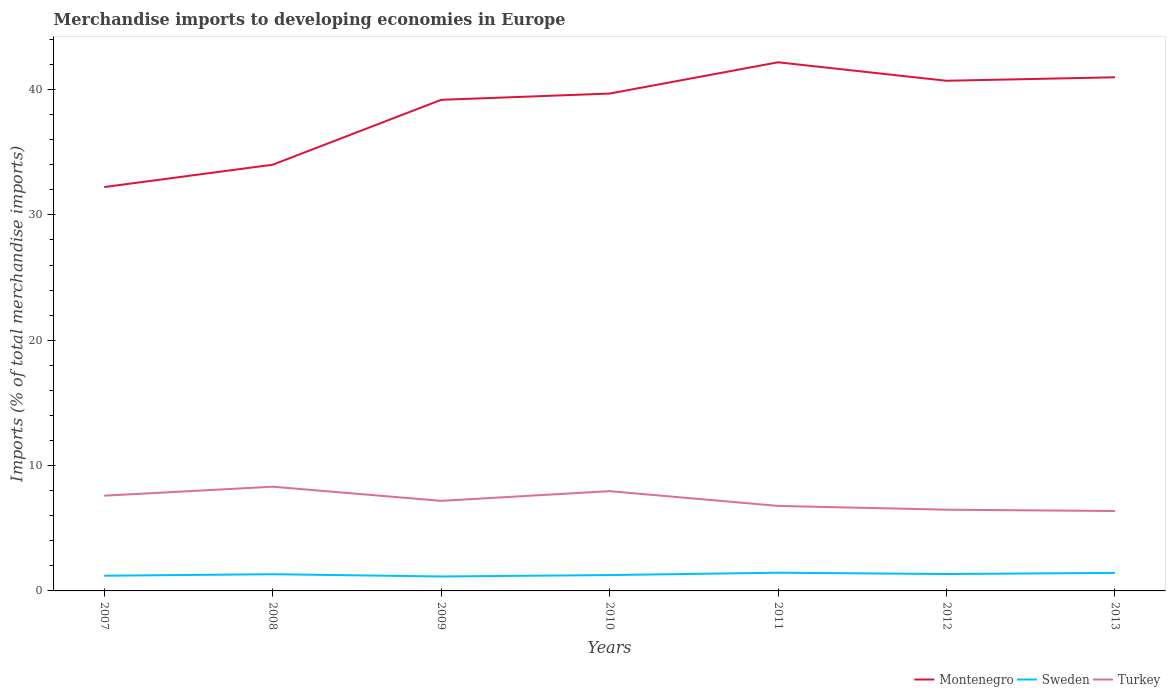How many different coloured lines are there?
Provide a succinct answer. 3. Does the line corresponding to Turkey intersect with the line corresponding to Sweden?
Offer a terse response. No. Across all years, what is the maximum percentage total merchandise imports in Sweden?
Ensure brevity in your answer.  1.15. In which year was the percentage total merchandise imports in Montenegro maximum?
Offer a very short reply. 2007. What is the total percentage total merchandise imports in Montenegro in the graph?
Offer a very short reply. 1.2. What is the difference between the highest and the second highest percentage total merchandise imports in Turkey?
Provide a succinct answer. 1.94. What is the difference between the highest and the lowest percentage total merchandise imports in Turkey?
Offer a terse response. 3. Is the percentage total merchandise imports in Sweden strictly greater than the percentage total merchandise imports in Turkey over the years?
Your answer should be very brief. Yes. How many years are there in the graph?
Provide a short and direct response. 7. Are the values on the major ticks of Y-axis written in scientific E-notation?
Provide a short and direct response. No. Does the graph contain any zero values?
Offer a very short reply. No. How many legend labels are there?
Your response must be concise. 3. How are the legend labels stacked?
Your answer should be very brief. Horizontal. What is the title of the graph?
Give a very brief answer. Merchandise imports to developing economies in Europe. Does "Bulgaria" appear as one of the legend labels in the graph?
Keep it short and to the point. No. What is the label or title of the Y-axis?
Make the answer very short. Imports (% of total merchandise imports). What is the Imports (% of total merchandise imports) of Montenegro in 2007?
Your answer should be very brief. 32.22. What is the Imports (% of total merchandise imports) of Sweden in 2007?
Offer a terse response. 1.21. What is the Imports (% of total merchandise imports) in Turkey in 2007?
Provide a short and direct response. 7.6. What is the Imports (% of total merchandise imports) in Montenegro in 2008?
Your answer should be very brief. 34. What is the Imports (% of total merchandise imports) of Sweden in 2008?
Offer a very short reply. 1.33. What is the Imports (% of total merchandise imports) of Turkey in 2008?
Ensure brevity in your answer.  8.31. What is the Imports (% of total merchandise imports) in Montenegro in 2009?
Provide a short and direct response. 39.18. What is the Imports (% of total merchandise imports) in Sweden in 2009?
Offer a terse response. 1.15. What is the Imports (% of total merchandise imports) of Turkey in 2009?
Make the answer very short. 7.19. What is the Imports (% of total merchandise imports) in Montenegro in 2010?
Provide a succinct answer. 39.68. What is the Imports (% of total merchandise imports) of Sweden in 2010?
Offer a terse response. 1.26. What is the Imports (% of total merchandise imports) in Turkey in 2010?
Make the answer very short. 7.96. What is the Imports (% of total merchandise imports) in Montenegro in 2011?
Offer a very short reply. 42.17. What is the Imports (% of total merchandise imports) in Sweden in 2011?
Your response must be concise. 1.45. What is the Imports (% of total merchandise imports) of Turkey in 2011?
Your response must be concise. 6.78. What is the Imports (% of total merchandise imports) of Montenegro in 2012?
Offer a terse response. 40.7. What is the Imports (% of total merchandise imports) in Sweden in 2012?
Offer a terse response. 1.35. What is the Imports (% of total merchandise imports) of Turkey in 2012?
Provide a succinct answer. 6.48. What is the Imports (% of total merchandise imports) in Montenegro in 2013?
Offer a terse response. 40.98. What is the Imports (% of total merchandise imports) in Sweden in 2013?
Offer a terse response. 1.44. What is the Imports (% of total merchandise imports) of Turkey in 2013?
Ensure brevity in your answer.  6.37. Across all years, what is the maximum Imports (% of total merchandise imports) of Montenegro?
Offer a terse response. 42.17. Across all years, what is the maximum Imports (% of total merchandise imports) of Sweden?
Make the answer very short. 1.45. Across all years, what is the maximum Imports (% of total merchandise imports) in Turkey?
Ensure brevity in your answer.  8.31. Across all years, what is the minimum Imports (% of total merchandise imports) in Montenegro?
Your response must be concise. 32.22. Across all years, what is the minimum Imports (% of total merchandise imports) of Sweden?
Provide a short and direct response. 1.15. Across all years, what is the minimum Imports (% of total merchandise imports) in Turkey?
Give a very brief answer. 6.37. What is the total Imports (% of total merchandise imports) in Montenegro in the graph?
Your response must be concise. 268.93. What is the total Imports (% of total merchandise imports) in Sweden in the graph?
Offer a terse response. 9.2. What is the total Imports (% of total merchandise imports) of Turkey in the graph?
Offer a terse response. 50.7. What is the difference between the Imports (% of total merchandise imports) of Montenegro in 2007 and that in 2008?
Keep it short and to the point. -1.78. What is the difference between the Imports (% of total merchandise imports) of Sweden in 2007 and that in 2008?
Keep it short and to the point. -0.12. What is the difference between the Imports (% of total merchandise imports) of Turkey in 2007 and that in 2008?
Keep it short and to the point. -0.72. What is the difference between the Imports (% of total merchandise imports) in Montenegro in 2007 and that in 2009?
Your answer should be compact. -6.96. What is the difference between the Imports (% of total merchandise imports) of Sweden in 2007 and that in 2009?
Offer a very short reply. 0.06. What is the difference between the Imports (% of total merchandise imports) in Turkey in 2007 and that in 2009?
Make the answer very short. 0.41. What is the difference between the Imports (% of total merchandise imports) in Montenegro in 2007 and that in 2010?
Your answer should be compact. -7.46. What is the difference between the Imports (% of total merchandise imports) of Sweden in 2007 and that in 2010?
Offer a very short reply. -0.05. What is the difference between the Imports (% of total merchandise imports) of Turkey in 2007 and that in 2010?
Provide a short and direct response. -0.36. What is the difference between the Imports (% of total merchandise imports) in Montenegro in 2007 and that in 2011?
Offer a terse response. -9.95. What is the difference between the Imports (% of total merchandise imports) of Sweden in 2007 and that in 2011?
Your answer should be very brief. -0.24. What is the difference between the Imports (% of total merchandise imports) in Turkey in 2007 and that in 2011?
Your response must be concise. 0.82. What is the difference between the Imports (% of total merchandise imports) of Montenegro in 2007 and that in 2012?
Give a very brief answer. -8.48. What is the difference between the Imports (% of total merchandise imports) of Sweden in 2007 and that in 2012?
Provide a short and direct response. -0.13. What is the difference between the Imports (% of total merchandise imports) in Turkey in 2007 and that in 2012?
Your answer should be compact. 1.12. What is the difference between the Imports (% of total merchandise imports) of Montenegro in 2007 and that in 2013?
Give a very brief answer. -8.76. What is the difference between the Imports (% of total merchandise imports) of Sweden in 2007 and that in 2013?
Offer a terse response. -0.23. What is the difference between the Imports (% of total merchandise imports) in Turkey in 2007 and that in 2013?
Keep it short and to the point. 1.22. What is the difference between the Imports (% of total merchandise imports) of Montenegro in 2008 and that in 2009?
Ensure brevity in your answer.  -5.18. What is the difference between the Imports (% of total merchandise imports) in Sweden in 2008 and that in 2009?
Make the answer very short. 0.18. What is the difference between the Imports (% of total merchandise imports) of Turkey in 2008 and that in 2009?
Keep it short and to the point. 1.13. What is the difference between the Imports (% of total merchandise imports) in Montenegro in 2008 and that in 2010?
Provide a succinct answer. -5.68. What is the difference between the Imports (% of total merchandise imports) in Sweden in 2008 and that in 2010?
Provide a short and direct response. 0.07. What is the difference between the Imports (% of total merchandise imports) in Turkey in 2008 and that in 2010?
Make the answer very short. 0.35. What is the difference between the Imports (% of total merchandise imports) in Montenegro in 2008 and that in 2011?
Keep it short and to the point. -8.17. What is the difference between the Imports (% of total merchandise imports) in Sweden in 2008 and that in 2011?
Make the answer very short. -0.12. What is the difference between the Imports (% of total merchandise imports) of Turkey in 2008 and that in 2011?
Ensure brevity in your answer.  1.53. What is the difference between the Imports (% of total merchandise imports) in Montenegro in 2008 and that in 2012?
Your answer should be compact. -6.7. What is the difference between the Imports (% of total merchandise imports) in Sweden in 2008 and that in 2012?
Offer a very short reply. -0.01. What is the difference between the Imports (% of total merchandise imports) of Turkey in 2008 and that in 2012?
Provide a short and direct response. 1.83. What is the difference between the Imports (% of total merchandise imports) of Montenegro in 2008 and that in 2013?
Give a very brief answer. -6.97. What is the difference between the Imports (% of total merchandise imports) in Sweden in 2008 and that in 2013?
Your answer should be compact. -0.11. What is the difference between the Imports (% of total merchandise imports) of Turkey in 2008 and that in 2013?
Your answer should be compact. 1.94. What is the difference between the Imports (% of total merchandise imports) of Montenegro in 2009 and that in 2010?
Provide a succinct answer. -0.5. What is the difference between the Imports (% of total merchandise imports) in Sweden in 2009 and that in 2010?
Offer a very short reply. -0.11. What is the difference between the Imports (% of total merchandise imports) of Turkey in 2009 and that in 2010?
Your answer should be very brief. -0.77. What is the difference between the Imports (% of total merchandise imports) of Montenegro in 2009 and that in 2011?
Offer a very short reply. -2.99. What is the difference between the Imports (% of total merchandise imports) in Sweden in 2009 and that in 2011?
Offer a very short reply. -0.3. What is the difference between the Imports (% of total merchandise imports) in Turkey in 2009 and that in 2011?
Your answer should be compact. 0.41. What is the difference between the Imports (% of total merchandise imports) of Montenegro in 2009 and that in 2012?
Your response must be concise. -1.52. What is the difference between the Imports (% of total merchandise imports) in Sweden in 2009 and that in 2012?
Keep it short and to the point. -0.19. What is the difference between the Imports (% of total merchandise imports) of Turkey in 2009 and that in 2012?
Offer a terse response. 0.71. What is the difference between the Imports (% of total merchandise imports) of Montenegro in 2009 and that in 2013?
Your answer should be very brief. -1.8. What is the difference between the Imports (% of total merchandise imports) of Sweden in 2009 and that in 2013?
Provide a short and direct response. -0.29. What is the difference between the Imports (% of total merchandise imports) in Turkey in 2009 and that in 2013?
Your answer should be very brief. 0.81. What is the difference between the Imports (% of total merchandise imports) of Montenegro in 2010 and that in 2011?
Ensure brevity in your answer.  -2.49. What is the difference between the Imports (% of total merchandise imports) of Sweden in 2010 and that in 2011?
Make the answer very short. -0.19. What is the difference between the Imports (% of total merchandise imports) of Turkey in 2010 and that in 2011?
Your response must be concise. 1.18. What is the difference between the Imports (% of total merchandise imports) in Montenegro in 2010 and that in 2012?
Make the answer very short. -1.02. What is the difference between the Imports (% of total merchandise imports) of Sweden in 2010 and that in 2012?
Ensure brevity in your answer.  -0.08. What is the difference between the Imports (% of total merchandise imports) in Turkey in 2010 and that in 2012?
Give a very brief answer. 1.48. What is the difference between the Imports (% of total merchandise imports) in Montenegro in 2010 and that in 2013?
Your answer should be compact. -1.3. What is the difference between the Imports (% of total merchandise imports) in Sweden in 2010 and that in 2013?
Make the answer very short. -0.18. What is the difference between the Imports (% of total merchandise imports) in Turkey in 2010 and that in 2013?
Give a very brief answer. 1.59. What is the difference between the Imports (% of total merchandise imports) of Montenegro in 2011 and that in 2012?
Provide a succinct answer. 1.47. What is the difference between the Imports (% of total merchandise imports) in Sweden in 2011 and that in 2012?
Provide a succinct answer. 0.11. What is the difference between the Imports (% of total merchandise imports) in Turkey in 2011 and that in 2012?
Ensure brevity in your answer.  0.3. What is the difference between the Imports (% of total merchandise imports) of Montenegro in 2011 and that in 2013?
Keep it short and to the point. 1.2. What is the difference between the Imports (% of total merchandise imports) in Sweden in 2011 and that in 2013?
Provide a short and direct response. 0.01. What is the difference between the Imports (% of total merchandise imports) of Turkey in 2011 and that in 2013?
Ensure brevity in your answer.  0.41. What is the difference between the Imports (% of total merchandise imports) in Montenegro in 2012 and that in 2013?
Give a very brief answer. -0.28. What is the difference between the Imports (% of total merchandise imports) of Sweden in 2012 and that in 2013?
Your answer should be compact. -0.09. What is the difference between the Imports (% of total merchandise imports) in Turkey in 2012 and that in 2013?
Offer a terse response. 0.11. What is the difference between the Imports (% of total merchandise imports) of Montenegro in 2007 and the Imports (% of total merchandise imports) of Sweden in 2008?
Give a very brief answer. 30.89. What is the difference between the Imports (% of total merchandise imports) in Montenegro in 2007 and the Imports (% of total merchandise imports) in Turkey in 2008?
Offer a very short reply. 23.9. What is the difference between the Imports (% of total merchandise imports) in Sweden in 2007 and the Imports (% of total merchandise imports) in Turkey in 2008?
Your answer should be very brief. -7.1. What is the difference between the Imports (% of total merchandise imports) in Montenegro in 2007 and the Imports (% of total merchandise imports) in Sweden in 2009?
Give a very brief answer. 31.07. What is the difference between the Imports (% of total merchandise imports) in Montenegro in 2007 and the Imports (% of total merchandise imports) in Turkey in 2009?
Offer a terse response. 25.03. What is the difference between the Imports (% of total merchandise imports) of Sweden in 2007 and the Imports (% of total merchandise imports) of Turkey in 2009?
Make the answer very short. -5.97. What is the difference between the Imports (% of total merchandise imports) of Montenegro in 2007 and the Imports (% of total merchandise imports) of Sweden in 2010?
Give a very brief answer. 30.95. What is the difference between the Imports (% of total merchandise imports) in Montenegro in 2007 and the Imports (% of total merchandise imports) in Turkey in 2010?
Ensure brevity in your answer.  24.26. What is the difference between the Imports (% of total merchandise imports) of Sweden in 2007 and the Imports (% of total merchandise imports) of Turkey in 2010?
Your answer should be compact. -6.75. What is the difference between the Imports (% of total merchandise imports) of Montenegro in 2007 and the Imports (% of total merchandise imports) of Sweden in 2011?
Ensure brevity in your answer.  30.76. What is the difference between the Imports (% of total merchandise imports) in Montenegro in 2007 and the Imports (% of total merchandise imports) in Turkey in 2011?
Provide a short and direct response. 25.44. What is the difference between the Imports (% of total merchandise imports) of Sweden in 2007 and the Imports (% of total merchandise imports) of Turkey in 2011?
Ensure brevity in your answer.  -5.57. What is the difference between the Imports (% of total merchandise imports) in Montenegro in 2007 and the Imports (% of total merchandise imports) in Sweden in 2012?
Your answer should be compact. 30.87. What is the difference between the Imports (% of total merchandise imports) in Montenegro in 2007 and the Imports (% of total merchandise imports) in Turkey in 2012?
Provide a short and direct response. 25.74. What is the difference between the Imports (% of total merchandise imports) in Sweden in 2007 and the Imports (% of total merchandise imports) in Turkey in 2012?
Provide a short and direct response. -5.27. What is the difference between the Imports (% of total merchandise imports) of Montenegro in 2007 and the Imports (% of total merchandise imports) of Sweden in 2013?
Keep it short and to the point. 30.78. What is the difference between the Imports (% of total merchandise imports) in Montenegro in 2007 and the Imports (% of total merchandise imports) in Turkey in 2013?
Offer a very short reply. 25.84. What is the difference between the Imports (% of total merchandise imports) in Sweden in 2007 and the Imports (% of total merchandise imports) in Turkey in 2013?
Provide a short and direct response. -5.16. What is the difference between the Imports (% of total merchandise imports) of Montenegro in 2008 and the Imports (% of total merchandise imports) of Sweden in 2009?
Give a very brief answer. 32.85. What is the difference between the Imports (% of total merchandise imports) in Montenegro in 2008 and the Imports (% of total merchandise imports) in Turkey in 2009?
Provide a short and direct response. 26.82. What is the difference between the Imports (% of total merchandise imports) of Sweden in 2008 and the Imports (% of total merchandise imports) of Turkey in 2009?
Your answer should be compact. -5.85. What is the difference between the Imports (% of total merchandise imports) in Montenegro in 2008 and the Imports (% of total merchandise imports) in Sweden in 2010?
Ensure brevity in your answer.  32.74. What is the difference between the Imports (% of total merchandise imports) of Montenegro in 2008 and the Imports (% of total merchandise imports) of Turkey in 2010?
Make the answer very short. 26.04. What is the difference between the Imports (% of total merchandise imports) in Sweden in 2008 and the Imports (% of total merchandise imports) in Turkey in 2010?
Ensure brevity in your answer.  -6.63. What is the difference between the Imports (% of total merchandise imports) of Montenegro in 2008 and the Imports (% of total merchandise imports) of Sweden in 2011?
Keep it short and to the point. 32.55. What is the difference between the Imports (% of total merchandise imports) of Montenegro in 2008 and the Imports (% of total merchandise imports) of Turkey in 2011?
Make the answer very short. 27.22. What is the difference between the Imports (% of total merchandise imports) in Sweden in 2008 and the Imports (% of total merchandise imports) in Turkey in 2011?
Your answer should be compact. -5.45. What is the difference between the Imports (% of total merchandise imports) of Montenegro in 2008 and the Imports (% of total merchandise imports) of Sweden in 2012?
Your response must be concise. 32.65. What is the difference between the Imports (% of total merchandise imports) of Montenegro in 2008 and the Imports (% of total merchandise imports) of Turkey in 2012?
Give a very brief answer. 27.52. What is the difference between the Imports (% of total merchandise imports) of Sweden in 2008 and the Imports (% of total merchandise imports) of Turkey in 2012?
Offer a terse response. -5.15. What is the difference between the Imports (% of total merchandise imports) of Montenegro in 2008 and the Imports (% of total merchandise imports) of Sweden in 2013?
Provide a succinct answer. 32.56. What is the difference between the Imports (% of total merchandise imports) in Montenegro in 2008 and the Imports (% of total merchandise imports) in Turkey in 2013?
Give a very brief answer. 27.63. What is the difference between the Imports (% of total merchandise imports) of Sweden in 2008 and the Imports (% of total merchandise imports) of Turkey in 2013?
Your answer should be very brief. -5.04. What is the difference between the Imports (% of total merchandise imports) of Montenegro in 2009 and the Imports (% of total merchandise imports) of Sweden in 2010?
Your answer should be very brief. 37.91. What is the difference between the Imports (% of total merchandise imports) in Montenegro in 2009 and the Imports (% of total merchandise imports) in Turkey in 2010?
Keep it short and to the point. 31.22. What is the difference between the Imports (% of total merchandise imports) of Sweden in 2009 and the Imports (% of total merchandise imports) of Turkey in 2010?
Provide a short and direct response. -6.81. What is the difference between the Imports (% of total merchandise imports) of Montenegro in 2009 and the Imports (% of total merchandise imports) of Sweden in 2011?
Provide a short and direct response. 37.72. What is the difference between the Imports (% of total merchandise imports) in Montenegro in 2009 and the Imports (% of total merchandise imports) in Turkey in 2011?
Your answer should be compact. 32.4. What is the difference between the Imports (% of total merchandise imports) of Sweden in 2009 and the Imports (% of total merchandise imports) of Turkey in 2011?
Make the answer very short. -5.63. What is the difference between the Imports (% of total merchandise imports) in Montenegro in 2009 and the Imports (% of total merchandise imports) in Sweden in 2012?
Provide a succinct answer. 37.83. What is the difference between the Imports (% of total merchandise imports) of Montenegro in 2009 and the Imports (% of total merchandise imports) of Turkey in 2012?
Provide a succinct answer. 32.7. What is the difference between the Imports (% of total merchandise imports) in Sweden in 2009 and the Imports (% of total merchandise imports) in Turkey in 2012?
Provide a succinct answer. -5.33. What is the difference between the Imports (% of total merchandise imports) in Montenegro in 2009 and the Imports (% of total merchandise imports) in Sweden in 2013?
Your answer should be compact. 37.74. What is the difference between the Imports (% of total merchandise imports) in Montenegro in 2009 and the Imports (% of total merchandise imports) in Turkey in 2013?
Give a very brief answer. 32.8. What is the difference between the Imports (% of total merchandise imports) in Sweden in 2009 and the Imports (% of total merchandise imports) in Turkey in 2013?
Offer a terse response. -5.22. What is the difference between the Imports (% of total merchandise imports) of Montenegro in 2010 and the Imports (% of total merchandise imports) of Sweden in 2011?
Your answer should be very brief. 38.22. What is the difference between the Imports (% of total merchandise imports) of Montenegro in 2010 and the Imports (% of total merchandise imports) of Turkey in 2011?
Ensure brevity in your answer.  32.9. What is the difference between the Imports (% of total merchandise imports) of Sweden in 2010 and the Imports (% of total merchandise imports) of Turkey in 2011?
Make the answer very short. -5.52. What is the difference between the Imports (% of total merchandise imports) of Montenegro in 2010 and the Imports (% of total merchandise imports) of Sweden in 2012?
Provide a succinct answer. 38.33. What is the difference between the Imports (% of total merchandise imports) of Montenegro in 2010 and the Imports (% of total merchandise imports) of Turkey in 2012?
Keep it short and to the point. 33.2. What is the difference between the Imports (% of total merchandise imports) in Sweden in 2010 and the Imports (% of total merchandise imports) in Turkey in 2012?
Your answer should be compact. -5.22. What is the difference between the Imports (% of total merchandise imports) of Montenegro in 2010 and the Imports (% of total merchandise imports) of Sweden in 2013?
Provide a short and direct response. 38.24. What is the difference between the Imports (% of total merchandise imports) in Montenegro in 2010 and the Imports (% of total merchandise imports) in Turkey in 2013?
Your response must be concise. 33.3. What is the difference between the Imports (% of total merchandise imports) in Sweden in 2010 and the Imports (% of total merchandise imports) in Turkey in 2013?
Provide a succinct answer. -5.11. What is the difference between the Imports (% of total merchandise imports) of Montenegro in 2011 and the Imports (% of total merchandise imports) of Sweden in 2012?
Provide a short and direct response. 40.83. What is the difference between the Imports (% of total merchandise imports) in Montenegro in 2011 and the Imports (% of total merchandise imports) in Turkey in 2012?
Keep it short and to the point. 35.69. What is the difference between the Imports (% of total merchandise imports) of Sweden in 2011 and the Imports (% of total merchandise imports) of Turkey in 2012?
Make the answer very short. -5.03. What is the difference between the Imports (% of total merchandise imports) of Montenegro in 2011 and the Imports (% of total merchandise imports) of Sweden in 2013?
Your answer should be compact. 40.73. What is the difference between the Imports (% of total merchandise imports) of Montenegro in 2011 and the Imports (% of total merchandise imports) of Turkey in 2013?
Provide a succinct answer. 35.8. What is the difference between the Imports (% of total merchandise imports) of Sweden in 2011 and the Imports (% of total merchandise imports) of Turkey in 2013?
Offer a terse response. -4.92. What is the difference between the Imports (% of total merchandise imports) in Montenegro in 2012 and the Imports (% of total merchandise imports) in Sweden in 2013?
Offer a very short reply. 39.26. What is the difference between the Imports (% of total merchandise imports) of Montenegro in 2012 and the Imports (% of total merchandise imports) of Turkey in 2013?
Ensure brevity in your answer.  34.32. What is the difference between the Imports (% of total merchandise imports) in Sweden in 2012 and the Imports (% of total merchandise imports) in Turkey in 2013?
Offer a terse response. -5.03. What is the average Imports (% of total merchandise imports) of Montenegro per year?
Make the answer very short. 38.42. What is the average Imports (% of total merchandise imports) of Sweden per year?
Make the answer very short. 1.31. What is the average Imports (% of total merchandise imports) of Turkey per year?
Ensure brevity in your answer.  7.24. In the year 2007, what is the difference between the Imports (% of total merchandise imports) of Montenegro and Imports (% of total merchandise imports) of Sweden?
Provide a succinct answer. 31.01. In the year 2007, what is the difference between the Imports (% of total merchandise imports) in Montenegro and Imports (% of total merchandise imports) in Turkey?
Your response must be concise. 24.62. In the year 2007, what is the difference between the Imports (% of total merchandise imports) in Sweden and Imports (% of total merchandise imports) in Turkey?
Provide a short and direct response. -6.38. In the year 2008, what is the difference between the Imports (% of total merchandise imports) of Montenegro and Imports (% of total merchandise imports) of Sweden?
Your answer should be compact. 32.67. In the year 2008, what is the difference between the Imports (% of total merchandise imports) of Montenegro and Imports (% of total merchandise imports) of Turkey?
Your answer should be compact. 25.69. In the year 2008, what is the difference between the Imports (% of total merchandise imports) in Sweden and Imports (% of total merchandise imports) in Turkey?
Your answer should be very brief. -6.98. In the year 2009, what is the difference between the Imports (% of total merchandise imports) of Montenegro and Imports (% of total merchandise imports) of Sweden?
Give a very brief answer. 38.03. In the year 2009, what is the difference between the Imports (% of total merchandise imports) in Montenegro and Imports (% of total merchandise imports) in Turkey?
Ensure brevity in your answer.  31.99. In the year 2009, what is the difference between the Imports (% of total merchandise imports) of Sweden and Imports (% of total merchandise imports) of Turkey?
Provide a succinct answer. -6.03. In the year 2010, what is the difference between the Imports (% of total merchandise imports) of Montenegro and Imports (% of total merchandise imports) of Sweden?
Provide a succinct answer. 38.41. In the year 2010, what is the difference between the Imports (% of total merchandise imports) in Montenegro and Imports (% of total merchandise imports) in Turkey?
Make the answer very short. 31.72. In the year 2010, what is the difference between the Imports (% of total merchandise imports) in Sweden and Imports (% of total merchandise imports) in Turkey?
Make the answer very short. -6.7. In the year 2011, what is the difference between the Imports (% of total merchandise imports) of Montenegro and Imports (% of total merchandise imports) of Sweden?
Your response must be concise. 40.72. In the year 2011, what is the difference between the Imports (% of total merchandise imports) of Montenegro and Imports (% of total merchandise imports) of Turkey?
Offer a terse response. 35.39. In the year 2011, what is the difference between the Imports (% of total merchandise imports) in Sweden and Imports (% of total merchandise imports) in Turkey?
Offer a terse response. -5.33. In the year 2012, what is the difference between the Imports (% of total merchandise imports) of Montenegro and Imports (% of total merchandise imports) of Sweden?
Your answer should be very brief. 39.35. In the year 2012, what is the difference between the Imports (% of total merchandise imports) in Montenegro and Imports (% of total merchandise imports) in Turkey?
Ensure brevity in your answer.  34.22. In the year 2012, what is the difference between the Imports (% of total merchandise imports) of Sweden and Imports (% of total merchandise imports) of Turkey?
Offer a terse response. -5.13. In the year 2013, what is the difference between the Imports (% of total merchandise imports) of Montenegro and Imports (% of total merchandise imports) of Sweden?
Your answer should be very brief. 39.54. In the year 2013, what is the difference between the Imports (% of total merchandise imports) in Montenegro and Imports (% of total merchandise imports) in Turkey?
Your answer should be very brief. 34.6. In the year 2013, what is the difference between the Imports (% of total merchandise imports) of Sweden and Imports (% of total merchandise imports) of Turkey?
Your answer should be compact. -4.93. What is the ratio of the Imports (% of total merchandise imports) in Montenegro in 2007 to that in 2008?
Make the answer very short. 0.95. What is the ratio of the Imports (% of total merchandise imports) in Sweden in 2007 to that in 2008?
Provide a short and direct response. 0.91. What is the ratio of the Imports (% of total merchandise imports) of Turkey in 2007 to that in 2008?
Give a very brief answer. 0.91. What is the ratio of the Imports (% of total merchandise imports) of Montenegro in 2007 to that in 2009?
Your response must be concise. 0.82. What is the ratio of the Imports (% of total merchandise imports) in Sweden in 2007 to that in 2009?
Provide a short and direct response. 1.05. What is the ratio of the Imports (% of total merchandise imports) in Turkey in 2007 to that in 2009?
Give a very brief answer. 1.06. What is the ratio of the Imports (% of total merchandise imports) in Montenegro in 2007 to that in 2010?
Keep it short and to the point. 0.81. What is the ratio of the Imports (% of total merchandise imports) of Turkey in 2007 to that in 2010?
Provide a succinct answer. 0.95. What is the ratio of the Imports (% of total merchandise imports) in Montenegro in 2007 to that in 2011?
Give a very brief answer. 0.76. What is the ratio of the Imports (% of total merchandise imports) of Sweden in 2007 to that in 2011?
Provide a short and direct response. 0.83. What is the ratio of the Imports (% of total merchandise imports) in Turkey in 2007 to that in 2011?
Offer a terse response. 1.12. What is the ratio of the Imports (% of total merchandise imports) in Montenegro in 2007 to that in 2012?
Offer a terse response. 0.79. What is the ratio of the Imports (% of total merchandise imports) of Sweden in 2007 to that in 2012?
Your answer should be compact. 0.9. What is the ratio of the Imports (% of total merchandise imports) of Turkey in 2007 to that in 2012?
Ensure brevity in your answer.  1.17. What is the ratio of the Imports (% of total merchandise imports) of Montenegro in 2007 to that in 2013?
Your answer should be very brief. 0.79. What is the ratio of the Imports (% of total merchandise imports) in Sweden in 2007 to that in 2013?
Ensure brevity in your answer.  0.84. What is the ratio of the Imports (% of total merchandise imports) of Turkey in 2007 to that in 2013?
Provide a succinct answer. 1.19. What is the ratio of the Imports (% of total merchandise imports) in Montenegro in 2008 to that in 2009?
Offer a very short reply. 0.87. What is the ratio of the Imports (% of total merchandise imports) in Sweden in 2008 to that in 2009?
Offer a very short reply. 1.16. What is the ratio of the Imports (% of total merchandise imports) in Turkey in 2008 to that in 2009?
Offer a terse response. 1.16. What is the ratio of the Imports (% of total merchandise imports) of Montenegro in 2008 to that in 2010?
Provide a succinct answer. 0.86. What is the ratio of the Imports (% of total merchandise imports) in Sweden in 2008 to that in 2010?
Keep it short and to the point. 1.05. What is the ratio of the Imports (% of total merchandise imports) of Turkey in 2008 to that in 2010?
Your answer should be compact. 1.04. What is the ratio of the Imports (% of total merchandise imports) of Montenegro in 2008 to that in 2011?
Make the answer very short. 0.81. What is the ratio of the Imports (% of total merchandise imports) of Sweden in 2008 to that in 2011?
Your answer should be very brief. 0.92. What is the ratio of the Imports (% of total merchandise imports) of Turkey in 2008 to that in 2011?
Offer a terse response. 1.23. What is the ratio of the Imports (% of total merchandise imports) in Montenegro in 2008 to that in 2012?
Offer a terse response. 0.84. What is the ratio of the Imports (% of total merchandise imports) of Turkey in 2008 to that in 2012?
Ensure brevity in your answer.  1.28. What is the ratio of the Imports (% of total merchandise imports) in Montenegro in 2008 to that in 2013?
Keep it short and to the point. 0.83. What is the ratio of the Imports (% of total merchandise imports) of Sweden in 2008 to that in 2013?
Your answer should be compact. 0.93. What is the ratio of the Imports (% of total merchandise imports) of Turkey in 2008 to that in 2013?
Provide a short and direct response. 1.3. What is the ratio of the Imports (% of total merchandise imports) of Montenegro in 2009 to that in 2010?
Offer a terse response. 0.99. What is the ratio of the Imports (% of total merchandise imports) of Sweden in 2009 to that in 2010?
Ensure brevity in your answer.  0.91. What is the ratio of the Imports (% of total merchandise imports) of Turkey in 2009 to that in 2010?
Offer a terse response. 0.9. What is the ratio of the Imports (% of total merchandise imports) of Montenegro in 2009 to that in 2011?
Keep it short and to the point. 0.93. What is the ratio of the Imports (% of total merchandise imports) in Sweden in 2009 to that in 2011?
Your answer should be compact. 0.79. What is the ratio of the Imports (% of total merchandise imports) of Turkey in 2009 to that in 2011?
Ensure brevity in your answer.  1.06. What is the ratio of the Imports (% of total merchandise imports) in Montenegro in 2009 to that in 2012?
Keep it short and to the point. 0.96. What is the ratio of the Imports (% of total merchandise imports) of Sweden in 2009 to that in 2012?
Offer a terse response. 0.86. What is the ratio of the Imports (% of total merchandise imports) of Turkey in 2009 to that in 2012?
Give a very brief answer. 1.11. What is the ratio of the Imports (% of total merchandise imports) of Montenegro in 2009 to that in 2013?
Give a very brief answer. 0.96. What is the ratio of the Imports (% of total merchandise imports) in Sweden in 2009 to that in 2013?
Your answer should be very brief. 0.8. What is the ratio of the Imports (% of total merchandise imports) of Turkey in 2009 to that in 2013?
Your answer should be compact. 1.13. What is the ratio of the Imports (% of total merchandise imports) of Montenegro in 2010 to that in 2011?
Provide a succinct answer. 0.94. What is the ratio of the Imports (% of total merchandise imports) of Sweden in 2010 to that in 2011?
Provide a succinct answer. 0.87. What is the ratio of the Imports (% of total merchandise imports) of Turkey in 2010 to that in 2011?
Provide a short and direct response. 1.17. What is the ratio of the Imports (% of total merchandise imports) in Montenegro in 2010 to that in 2012?
Ensure brevity in your answer.  0.97. What is the ratio of the Imports (% of total merchandise imports) of Sweden in 2010 to that in 2012?
Your answer should be compact. 0.94. What is the ratio of the Imports (% of total merchandise imports) in Turkey in 2010 to that in 2012?
Give a very brief answer. 1.23. What is the ratio of the Imports (% of total merchandise imports) of Montenegro in 2010 to that in 2013?
Offer a terse response. 0.97. What is the ratio of the Imports (% of total merchandise imports) in Sweden in 2010 to that in 2013?
Provide a short and direct response. 0.88. What is the ratio of the Imports (% of total merchandise imports) in Turkey in 2010 to that in 2013?
Provide a short and direct response. 1.25. What is the ratio of the Imports (% of total merchandise imports) in Montenegro in 2011 to that in 2012?
Keep it short and to the point. 1.04. What is the ratio of the Imports (% of total merchandise imports) of Sweden in 2011 to that in 2012?
Offer a very short reply. 1.08. What is the ratio of the Imports (% of total merchandise imports) of Turkey in 2011 to that in 2012?
Your answer should be very brief. 1.05. What is the ratio of the Imports (% of total merchandise imports) in Montenegro in 2011 to that in 2013?
Provide a short and direct response. 1.03. What is the ratio of the Imports (% of total merchandise imports) of Sweden in 2011 to that in 2013?
Your answer should be compact. 1.01. What is the ratio of the Imports (% of total merchandise imports) of Turkey in 2011 to that in 2013?
Provide a short and direct response. 1.06. What is the ratio of the Imports (% of total merchandise imports) of Montenegro in 2012 to that in 2013?
Keep it short and to the point. 0.99. What is the ratio of the Imports (% of total merchandise imports) of Sweden in 2012 to that in 2013?
Offer a terse response. 0.94. What is the ratio of the Imports (% of total merchandise imports) of Turkey in 2012 to that in 2013?
Your answer should be compact. 1.02. What is the difference between the highest and the second highest Imports (% of total merchandise imports) in Montenegro?
Offer a very short reply. 1.2. What is the difference between the highest and the second highest Imports (% of total merchandise imports) of Sweden?
Give a very brief answer. 0.01. What is the difference between the highest and the second highest Imports (% of total merchandise imports) of Turkey?
Ensure brevity in your answer.  0.35. What is the difference between the highest and the lowest Imports (% of total merchandise imports) in Montenegro?
Provide a short and direct response. 9.95. What is the difference between the highest and the lowest Imports (% of total merchandise imports) in Sweden?
Provide a succinct answer. 0.3. What is the difference between the highest and the lowest Imports (% of total merchandise imports) in Turkey?
Provide a succinct answer. 1.94. 